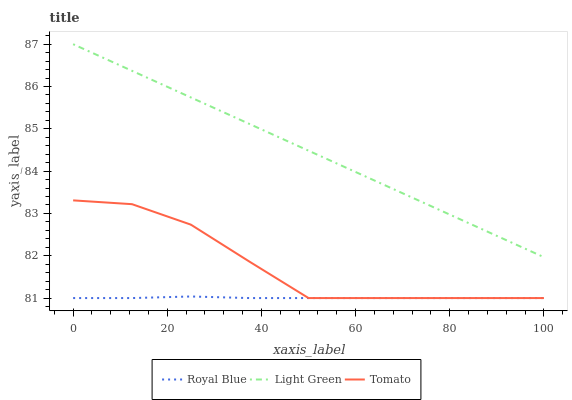Does Royal Blue have the minimum area under the curve?
Answer yes or no. Yes. Does Light Green have the maximum area under the curve?
Answer yes or no. Yes. Does Light Green have the minimum area under the curve?
Answer yes or no. No. Does Royal Blue have the maximum area under the curve?
Answer yes or no. No. Is Light Green the smoothest?
Answer yes or no. Yes. Is Tomato the roughest?
Answer yes or no. Yes. Is Royal Blue the smoothest?
Answer yes or no. No. Is Royal Blue the roughest?
Answer yes or no. No. Does Tomato have the lowest value?
Answer yes or no. Yes. Does Light Green have the lowest value?
Answer yes or no. No. Does Light Green have the highest value?
Answer yes or no. Yes. Does Royal Blue have the highest value?
Answer yes or no. No. Is Tomato less than Light Green?
Answer yes or no. Yes. Is Light Green greater than Royal Blue?
Answer yes or no. Yes. Does Royal Blue intersect Tomato?
Answer yes or no. Yes. Is Royal Blue less than Tomato?
Answer yes or no. No. Is Royal Blue greater than Tomato?
Answer yes or no. No. Does Tomato intersect Light Green?
Answer yes or no. No. 